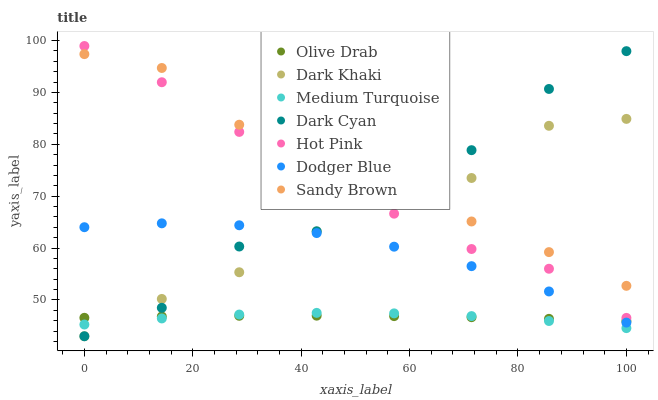Does Medium Turquoise have the minimum area under the curve?
Answer yes or no. Yes. Does Sandy Brown have the maximum area under the curve?
Answer yes or no. Yes. Does Dark Khaki have the minimum area under the curve?
Answer yes or no. No. Does Dark Khaki have the maximum area under the curve?
Answer yes or no. No. Is Olive Drab the smoothest?
Answer yes or no. Yes. Is Dark Cyan the roughest?
Answer yes or no. Yes. Is Dark Khaki the smoothest?
Answer yes or no. No. Is Dark Khaki the roughest?
Answer yes or no. No. Does Dark Khaki have the lowest value?
Answer yes or no. Yes. Does Dodger Blue have the lowest value?
Answer yes or no. No. Does Hot Pink have the highest value?
Answer yes or no. Yes. Does Dark Khaki have the highest value?
Answer yes or no. No. Is Olive Drab less than Sandy Brown?
Answer yes or no. Yes. Is Sandy Brown greater than Medium Turquoise?
Answer yes or no. Yes. Does Dark Cyan intersect Sandy Brown?
Answer yes or no. Yes. Is Dark Cyan less than Sandy Brown?
Answer yes or no. No. Is Dark Cyan greater than Sandy Brown?
Answer yes or no. No. Does Olive Drab intersect Sandy Brown?
Answer yes or no. No. 